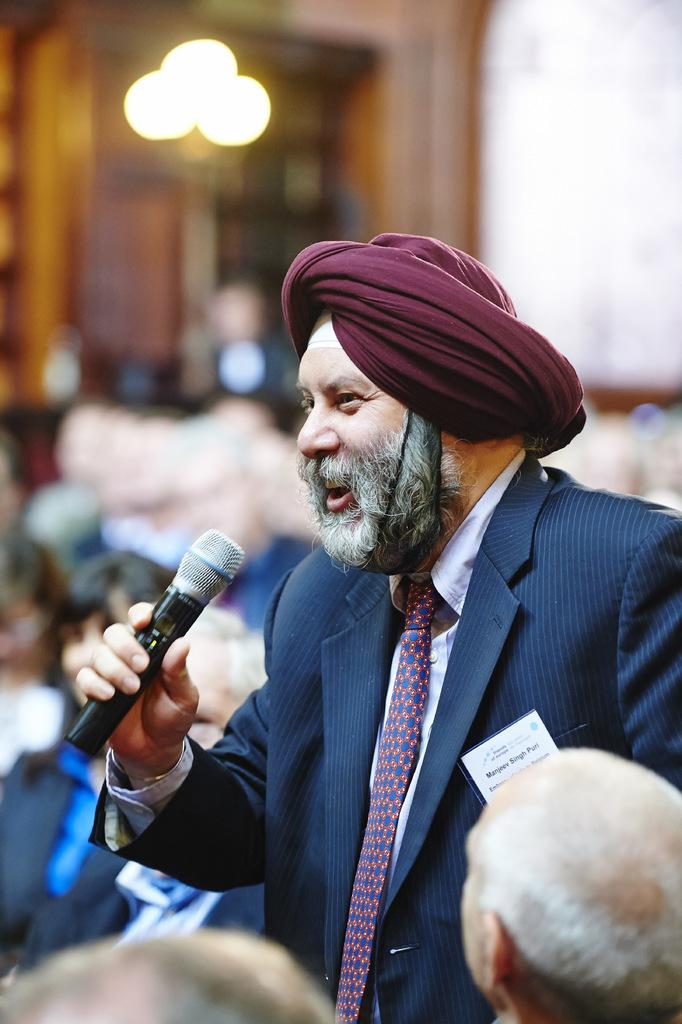What is the person in the image doing? The person is standing in the image and holding a microphone in his hand. What is the person wearing? The person is wearing a suit. How many people are around the person in the image? There are many people around the person in the image. What type of account does the person in the image have with the bank? There is no information about the person's bank account in the image, so it cannot be determined. 